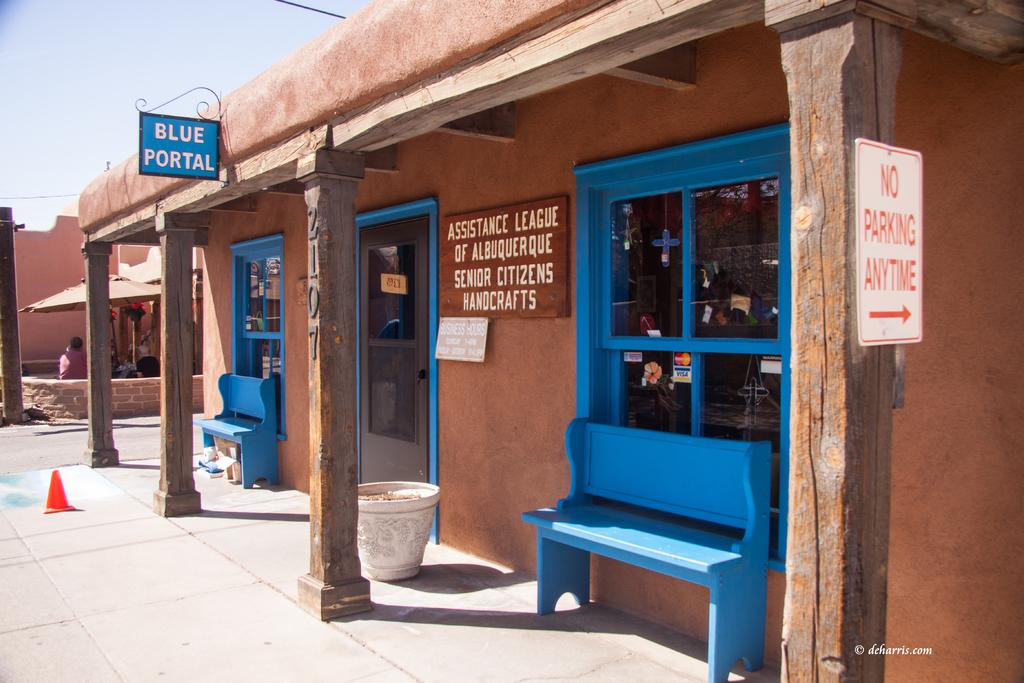What is the name of the store in the image? The store is named "Blue Portal." What type of products does the store sell? The store sells handicrafts. Who makes the handicrafts that are sold in the store? The handicrafts are made by senior citizens. How many mice can be seen running around the store in the image? There are no mice visible in the image. What does the mom of the store owner do in the store? The image does not provide information about the store owner's mom, so we cannot determine her role in the store. 